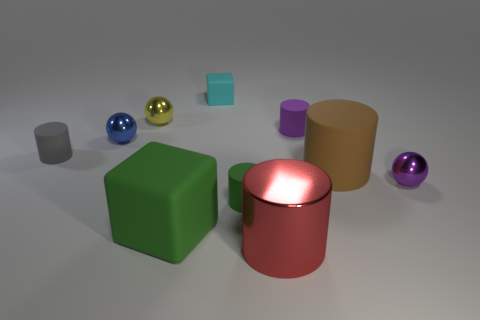Subtract 2 cylinders. How many cylinders are left? 3 Subtract all purple cylinders. How many cylinders are left? 4 Subtract all cyan cylinders. Subtract all gray balls. How many cylinders are left? 5 Subtract all spheres. How many objects are left? 7 Subtract 1 brown cylinders. How many objects are left? 9 Subtract all big cubes. Subtract all big rubber objects. How many objects are left? 7 Add 6 tiny blue metallic things. How many tiny blue metallic things are left? 7 Add 4 yellow balls. How many yellow balls exist? 5 